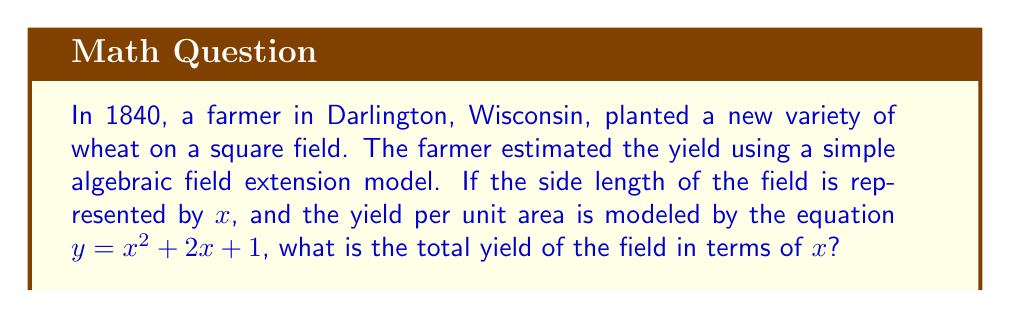Can you solve this math problem? To solve this problem, we'll follow these steps:

1) The field is square, so its area is given by $x^2$.

2) The yield per unit area is modeled by $y = x^2 + 2x + 1$.

3) To find the total yield, we need to multiply the area of the field by the yield per unit area:

   Total Yield = Area × Yield per unit area
   $$ \text{Total Yield} = x^2 \cdot (x^2 + 2x + 1) $$

4) Let's expand this expression:
   $$ \text{Total Yield} = x^2 \cdot x^2 + x^2 \cdot 2x + x^2 \cdot 1 $$

5) Simplify:
   $$ \text{Total Yield} = x^4 + 2x^3 + x^2 $$

This polynomial represents the total yield of the field in terms of $x$.
Answer: $x^4 + 2x^3 + x^2$ 